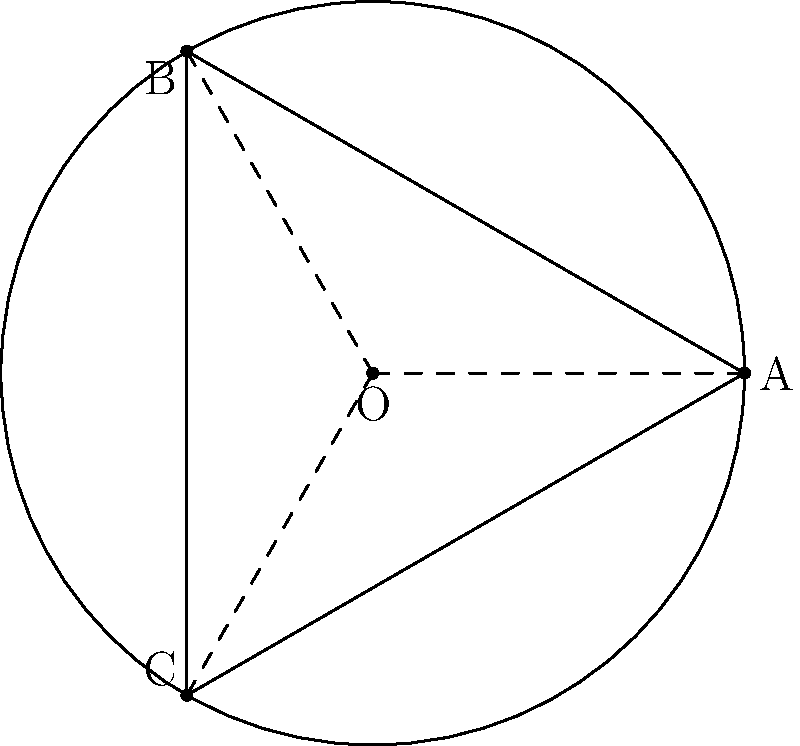In your circular dining area with radius 3 meters, you want to optimize the arrangement of large round tables. If you place three tables so that they touch each other and the edge of the dining area, what is the maximum radius of each table in meters? Let's approach this step-by-step:

1) The large tables form an equilateral triangle inscribed in the circle of the dining area.

2) The radius of the dining area is 3 meters. Let's call the radius of each table $x$ meters.

3) In an equilateral triangle, the distance from the center to any vertex is equal to the radius of the circumscribed circle. This distance is $3 - x$ (the radius of the dining area minus the radius of a table).

4) In an equilateral triangle, the relationship between the radius of the inscribed circle ($x$) and the radius of the circumscribed circle ($3-x$) is:

   $$(3-x) = \frac{2x}{\sqrt{3}}$$

5) Solving this equation:

   $$3-x = \frac{2x}{\sqrt{3}}$$
   $$3\sqrt{3} - x\sqrt{3} = 2x$$
   $$3\sqrt{3} = x\sqrt{3} + 2x = x(\sqrt{3} + 2)$$
   $$x = \frac{3\sqrt{3}}{\sqrt{3} + 2}$$

6) Simplifying:
   
   $$x = \frac{3\sqrt{3}(\sqrt{3} - 1)}{(\sqrt{3} + 2)(\sqrt{3} - 1)} = \frac{3(\sqrt{3} - 1)}{3 + 1} = \frac{3\sqrt{3} - 3}{4} = \frac{3(\sqrt{3} - 1)}{4}$$

Therefore, the maximum radius of each table is $\frac{3(\sqrt{3} - 1)}{4}$ meters.
Answer: $\frac{3(\sqrt{3} - 1)}{4}$ meters 